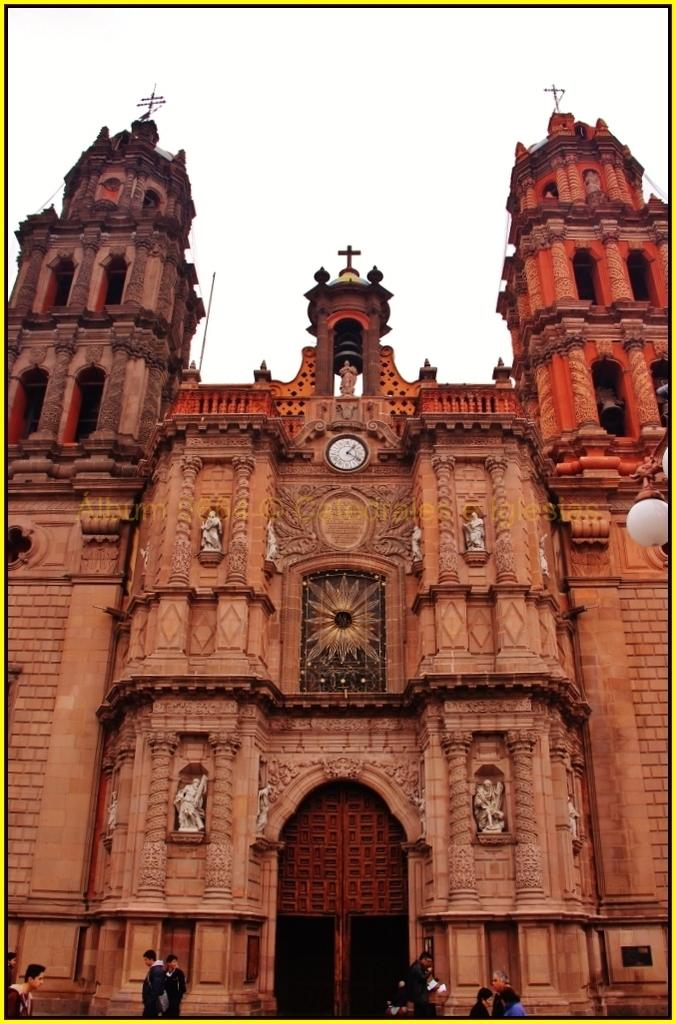What structure is the main subject of the image? There is a building in the image. What is happening in front of the building? There is a group of people in front of the building. What can be seen on the left side of the image? There are lights on the left side of the image. What time-related object is visible in the image? There is a clock visible in the image. Can you tell me how many dogs are sitting next to the rose in the image? There are no dogs or roses present in the image. 